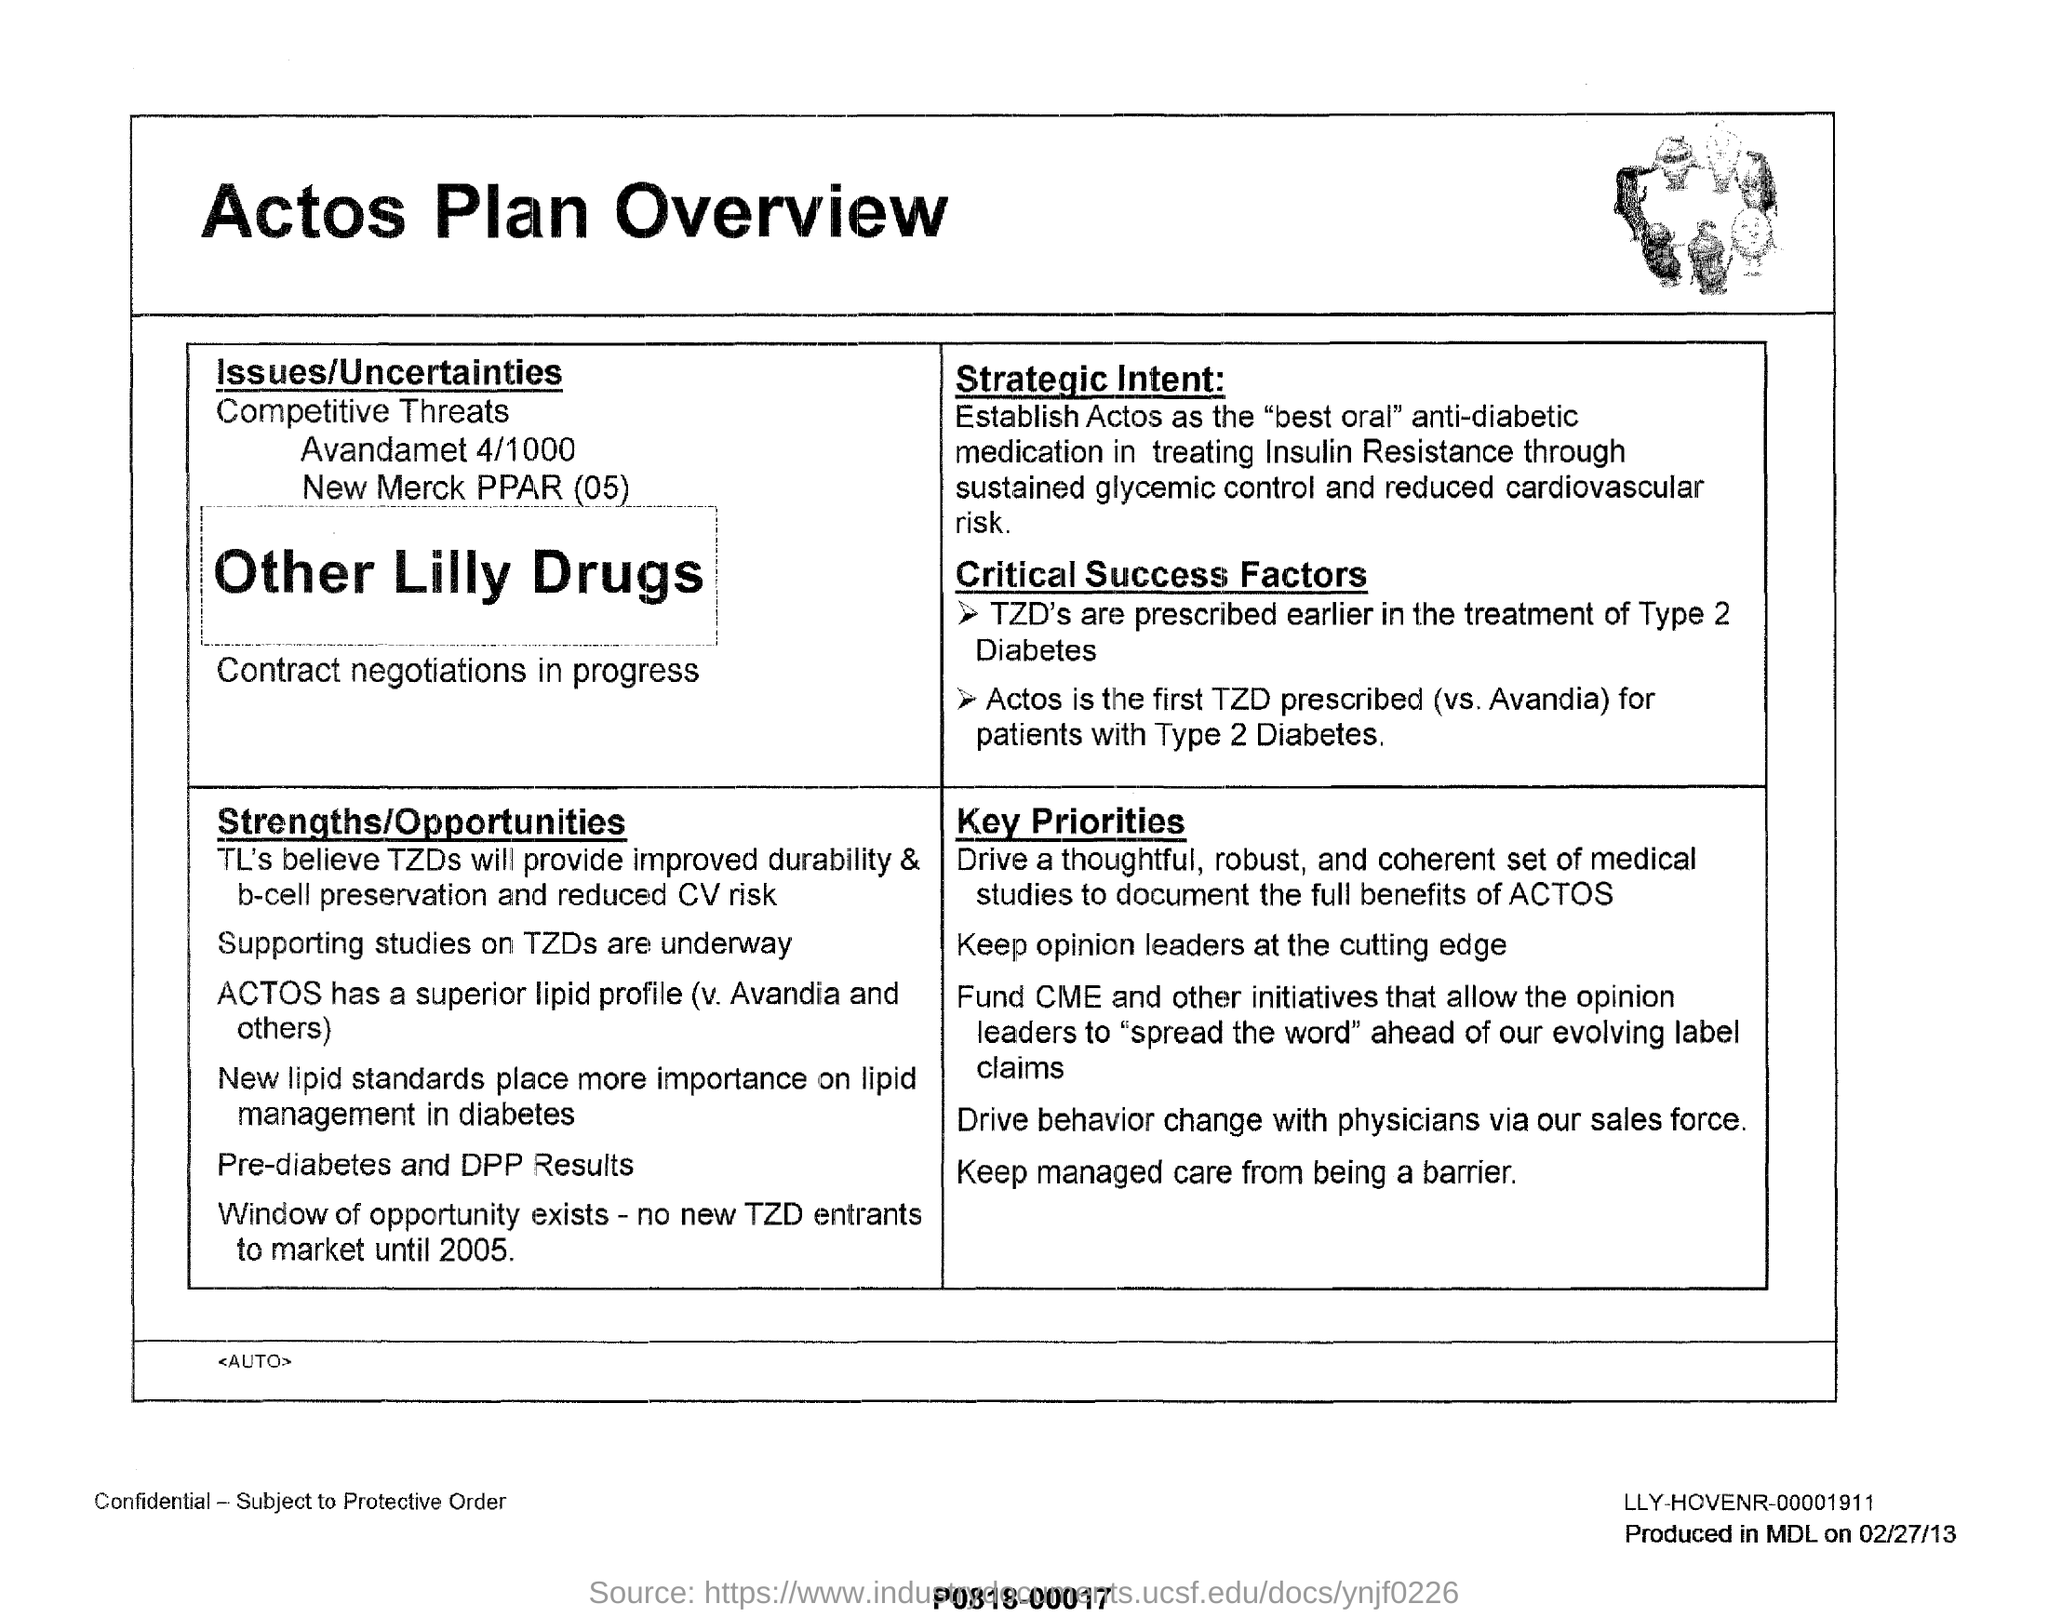Give some essential details in this illustration. The title of this page is 'ACTOS PLAN OVERVIEW.' The TZDs, which were previously prescribed for the treatment of Type 2 diabetes, are known as critical success factors for achieving good glycemic control. Actos, which has a superior lipid profile compared to drugs such as Avandia, presents significant strengths and opportunities in the market. 